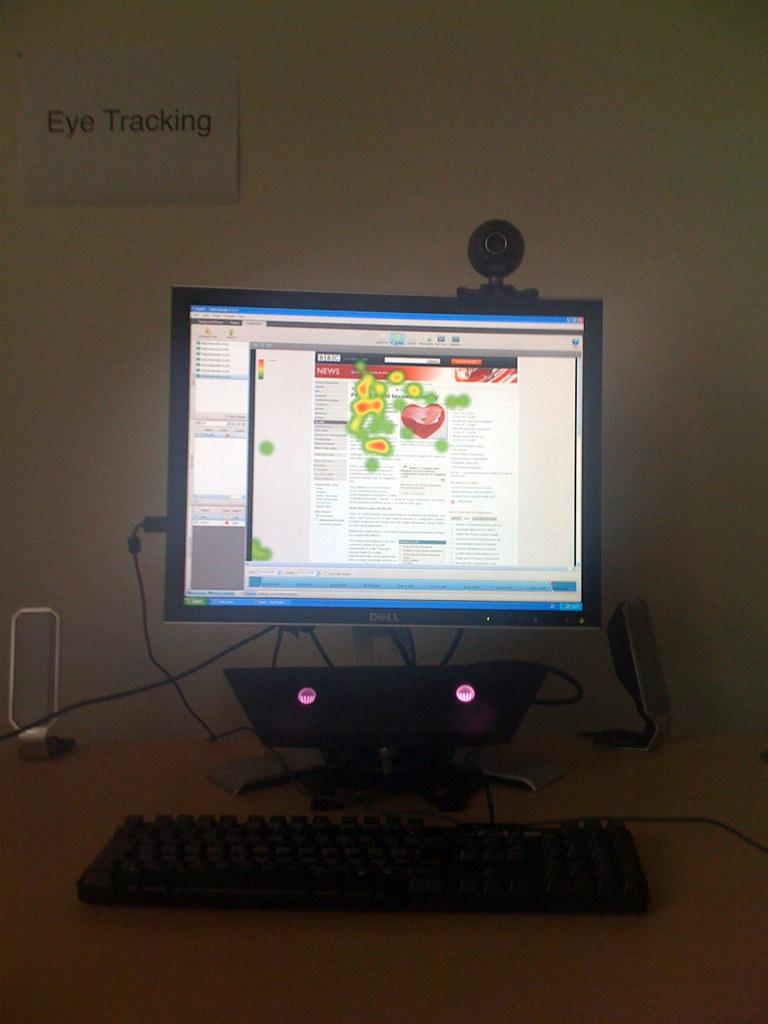<image>
Write a terse but informative summary of the picture. Eye Tracking reads the sign above the computer monitor. 